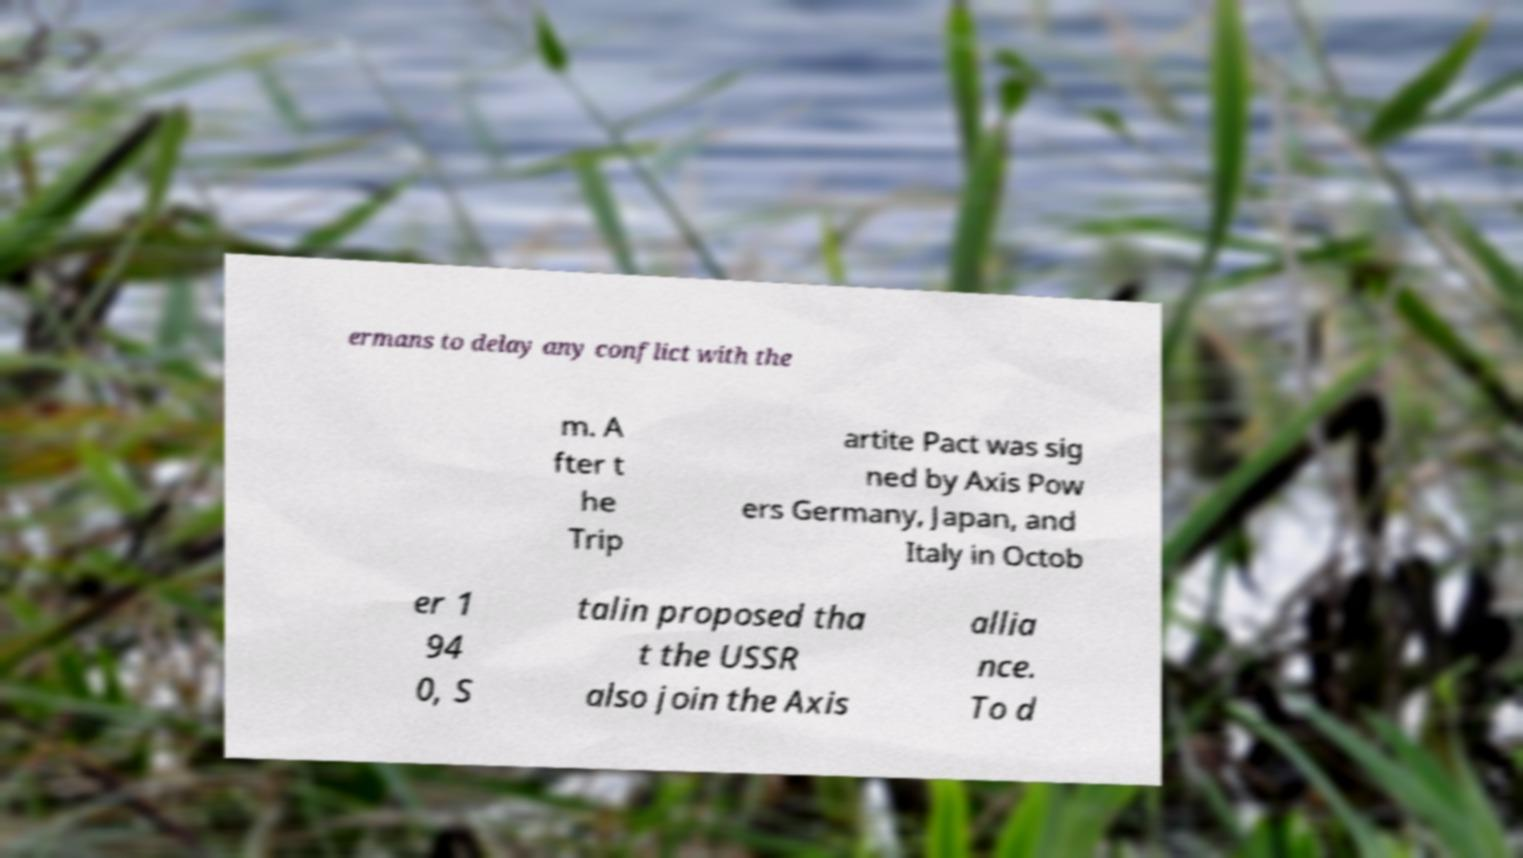Could you extract and type out the text from this image? ermans to delay any conflict with the m. A fter t he Trip artite Pact was sig ned by Axis Pow ers Germany, Japan, and Italy in Octob er 1 94 0, S talin proposed tha t the USSR also join the Axis allia nce. To d 